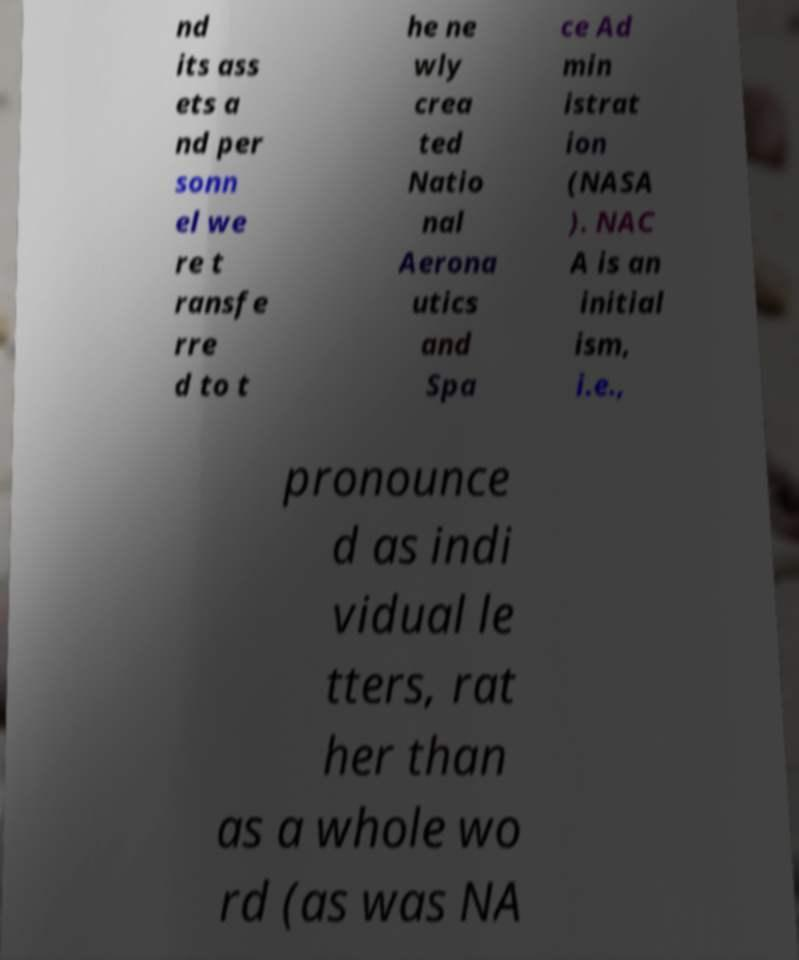What messages or text are displayed in this image? I need them in a readable, typed format. nd its ass ets a nd per sonn el we re t ransfe rre d to t he ne wly crea ted Natio nal Aerona utics and Spa ce Ad min istrat ion (NASA ). NAC A is an initial ism, i.e., pronounce d as indi vidual le tters, rat her than as a whole wo rd (as was NA 